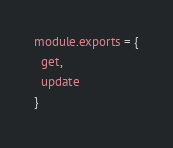Convert code to text. <code><loc_0><loc_0><loc_500><loc_500><_JavaScript_>module.exports = {
  get,
  update
}
</code> 